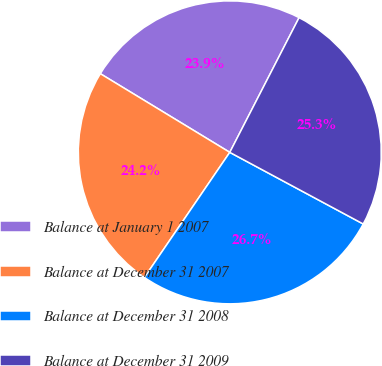Convert chart to OTSL. <chart><loc_0><loc_0><loc_500><loc_500><pie_chart><fcel>Balance at January 1 2007<fcel>Balance at December 31 2007<fcel>Balance at December 31 2008<fcel>Balance at December 31 2009<nl><fcel>23.87%<fcel>24.16%<fcel>26.69%<fcel>25.28%<nl></chart> 